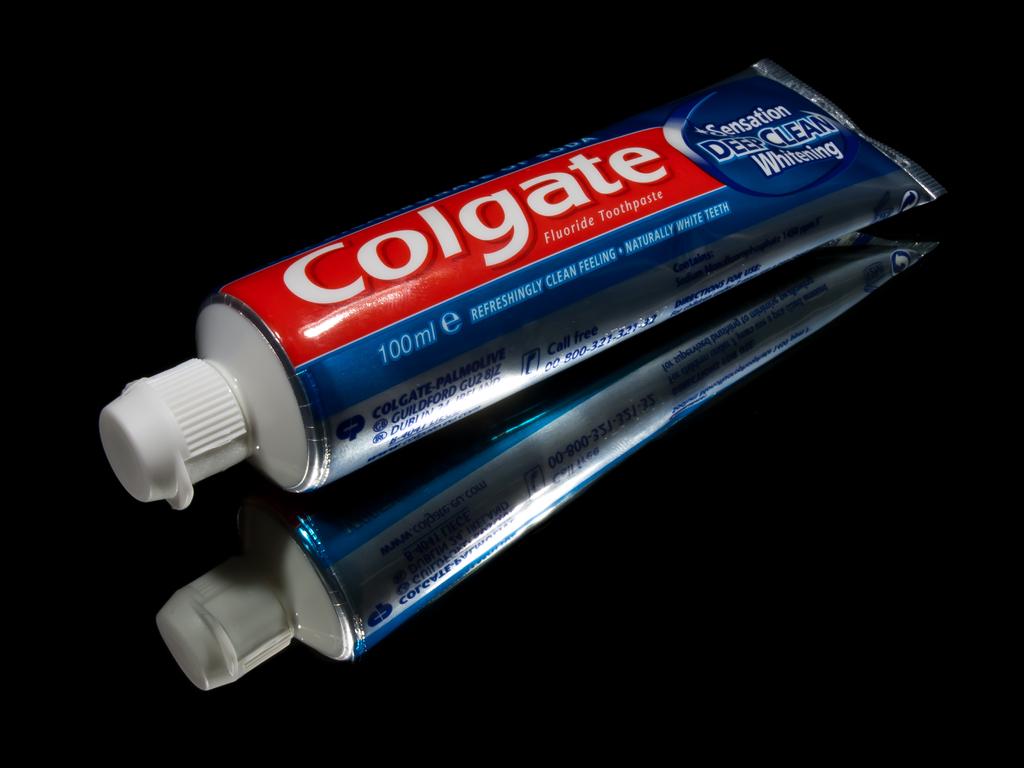Does colgate prevent cavities?
Provide a succinct answer. Yes. What is the brand of toothpaste?
Offer a very short reply. Colgate. 